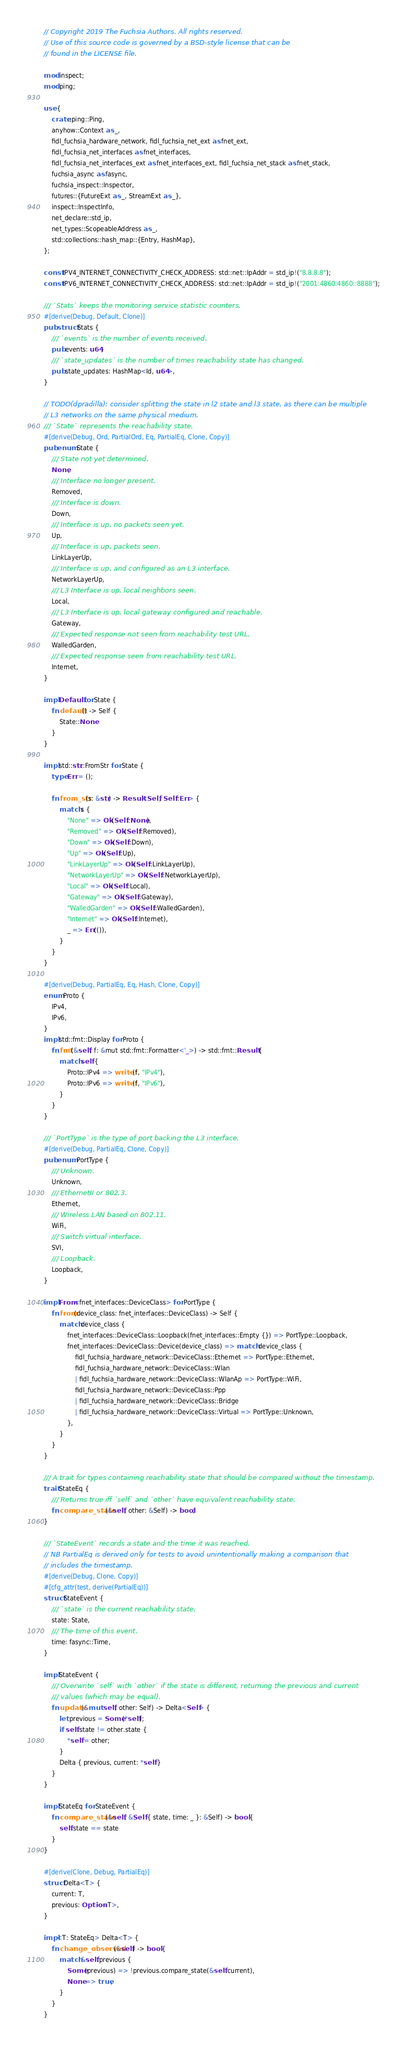<code> <loc_0><loc_0><loc_500><loc_500><_Rust_>// Copyright 2019 The Fuchsia Authors. All rights reserved.
// Use of this source code is governed by a BSD-style license that can be
// found in the LICENSE file.

mod inspect;
mod ping;

use {
    crate::ping::Ping,
    anyhow::Context as _,
    fidl_fuchsia_hardware_network, fidl_fuchsia_net_ext as fnet_ext,
    fidl_fuchsia_net_interfaces as fnet_interfaces,
    fidl_fuchsia_net_interfaces_ext as fnet_interfaces_ext, fidl_fuchsia_net_stack as fnet_stack,
    fuchsia_async as fasync,
    fuchsia_inspect::Inspector,
    futures::{FutureExt as _, StreamExt as _},
    inspect::InspectInfo,
    net_declare::std_ip,
    net_types::ScopeableAddress as _,
    std::collections::hash_map::{Entry, HashMap},
};

const IPV4_INTERNET_CONNECTIVITY_CHECK_ADDRESS: std::net::IpAddr = std_ip!("8.8.8.8");
const IPV6_INTERNET_CONNECTIVITY_CHECK_ADDRESS: std::net::IpAddr = std_ip!("2001:4860:4860::8888");

/// `Stats` keeps the monitoring service statistic counters.
#[derive(Debug, Default, Clone)]
pub struct Stats {
    /// `events` is the number of events received.
    pub events: u64,
    /// `state_updates` is the number of times reachability state has changed.
    pub state_updates: HashMap<Id, u64>,
}

// TODO(dpradilla): consider splitting the state in l2 state and l3 state, as there can be multiple
// L3 networks on the same physical medium.
/// `State` represents the reachability state.
#[derive(Debug, Ord, PartialOrd, Eq, PartialEq, Clone, Copy)]
pub enum State {
    /// State not yet determined.
    None,
    /// Interface no longer present.
    Removed,
    /// Interface is down.
    Down,
    /// Interface is up, no packets seen yet.
    Up,
    /// Interface is up, packets seen.
    LinkLayerUp,
    /// Interface is up, and configured as an L3 interface.
    NetworkLayerUp,
    /// L3 Interface is up, local neighbors seen.
    Local,
    /// L3 Interface is up, local gateway configured and reachable.
    Gateway,
    /// Expected response not seen from reachability test URL.
    WalledGarden,
    /// Expected response seen from reachability test URL.
    Internet,
}

impl Default for State {
    fn default() -> Self {
        State::None
    }
}

impl std::str::FromStr for State {
    type Err = ();

    fn from_str(s: &str) -> Result<Self, Self::Err> {
        match s {
            "None" => Ok(Self::None),
            "Removed" => Ok(Self::Removed),
            "Down" => Ok(Self::Down),
            "Up" => Ok(Self::Up),
            "LinkLayerUp" => Ok(Self::LinkLayerUp),
            "NetworkLayerUp" => Ok(Self::NetworkLayerUp),
            "Local" => Ok(Self::Local),
            "Gateway" => Ok(Self::Gateway),
            "WalledGarden" => Ok(Self::WalledGarden),
            "Internet" => Ok(Self::Internet),
            _ => Err(()),
        }
    }
}

#[derive(Debug, PartialEq, Eq, Hash, Clone, Copy)]
enum Proto {
    IPv4,
    IPv6,
}
impl std::fmt::Display for Proto {
    fn fmt(&self, f: &mut std::fmt::Formatter<'_>) -> std::fmt::Result {
        match self {
            Proto::IPv4 => write!(f, "IPv4"),
            Proto::IPv6 => write!(f, "IPv6"),
        }
    }
}

/// `PortType` is the type of port backing the L3 interface.
#[derive(Debug, PartialEq, Clone, Copy)]
pub enum PortType {
    /// Unknown.
    Unknown,
    /// EthernetII or 802.3.
    Ethernet,
    /// Wireless LAN based on 802.11.
    WiFi,
    /// Switch virtual interface.
    SVI,
    /// Loopback.
    Loopback,
}

impl From<fnet_interfaces::DeviceClass> for PortType {
    fn from(device_class: fnet_interfaces::DeviceClass) -> Self {
        match device_class {
            fnet_interfaces::DeviceClass::Loopback(fnet_interfaces::Empty {}) => PortType::Loopback,
            fnet_interfaces::DeviceClass::Device(device_class) => match device_class {
                fidl_fuchsia_hardware_network::DeviceClass::Ethernet => PortType::Ethernet,
                fidl_fuchsia_hardware_network::DeviceClass::Wlan
                | fidl_fuchsia_hardware_network::DeviceClass::WlanAp => PortType::WiFi,
                fidl_fuchsia_hardware_network::DeviceClass::Ppp
                | fidl_fuchsia_hardware_network::DeviceClass::Bridge
                | fidl_fuchsia_hardware_network::DeviceClass::Virtual => PortType::Unknown,
            },
        }
    }
}

/// A trait for types containing reachability state that should be compared without the timestamp.
trait StateEq {
    /// Returns true iff `self` and `other` have equivalent reachability state.
    fn compare_state(&self, other: &Self) -> bool;
}

/// `StateEvent` records a state and the time it was reached.
// NB PartialEq is derived only for tests to avoid unintentionally making a comparison that
// includes the timestamp.
#[derive(Debug, Clone, Copy)]
#[cfg_attr(test, derive(PartialEq))]
struct StateEvent {
    /// `state` is the current reachability state.
    state: State,
    /// The time of this event.
    time: fasync::Time,
}

impl StateEvent {
    /// Overwrite `self` with `other` if the state is different, returning the previous and current
    /// values (which may be equal).
    fn update(&mut self, other: Self) -> Delta<Self> {
        let previous = Some(*self);
        if self.state != other.state {
            *self = other;
        }
        Delta { previous, current: *self }
    }
}

impl StateEq for StateEvent {
    fn compare_state(&self, &Self { state, time: _ }: &Self) -> bool {
        self.state == state
    }
}

#[derive(Clone, Debug, PartialEq)]
struct Delta<T> {
    current: T,
    previous: Option<T>,
}

impl<T: StateEq> Delta<T> {
    fn change_observed(&self) -> bool {
        match &self.previous {
            Some(previous) => !previous.compare_state(&self.current),
            None => true,
        }
    }
}
</code> 